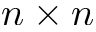<formula> <loc_0><loc_0><loc_500><loc_500>n \times n</formula> 